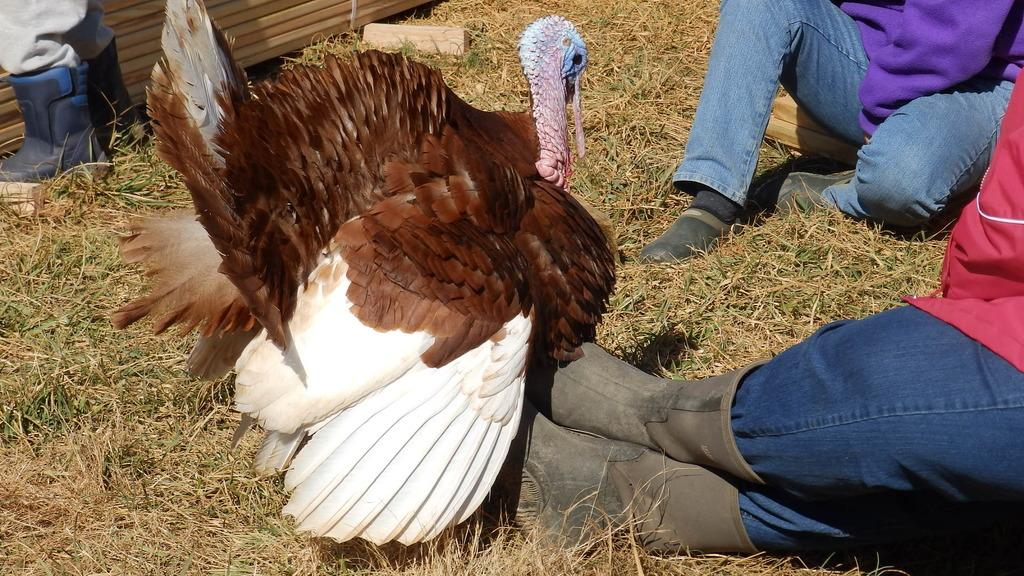What animal is present in the image? There is a turkey in the image. What type of vegetation can be seen in the image? There is grass in the image. What part of a person can be seen in the image? Human legs with footwear are visible in the image. What type of rose is being used as a hat by the turkey in the image? There is no rose present in the image, and the turkey is not wearing a hat. 